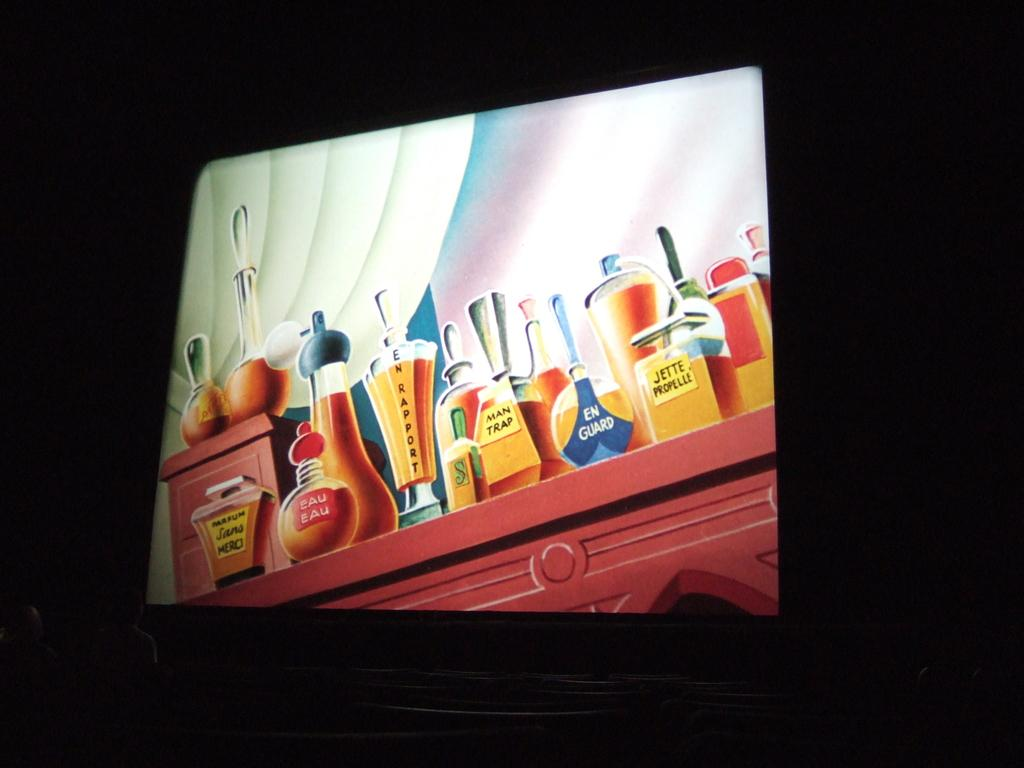<image>
Create a compact narrative representing the image presented. A screen grab of a coolourful cartoon of perfume bottles called en guard and eau eau amongst others. 